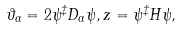Convert formula to latex. <formula><loc_0><loc_0><loc_500><loc_500>\vartheta _ { \alpha } = 2 \psi ^ { \ddagger } D _ { \alpha } \psi , z = \psi ^ { \ddagger } H \psi ,</formula> 